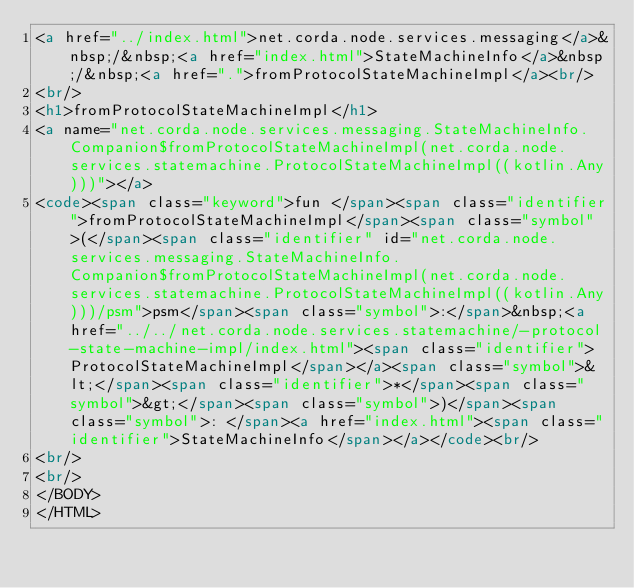Convert code to text. <code><loc_0><loc_0><loc_500><loc_500><_HTML_><a href="../index.html">net.corda.node.services.messaging</a>&nbsp;/&nbsp;<a href="index.html">StateMachineInfo</a>&nbsp;/&nbsp;<a href=".">fromProtocolStateMachineImpl</a><br/>
<br/>
<h1>fromProtocolStateMachineImpl</h1>
<a name="net.corda.node.services.messaging.StateMachineInfo.Companion$fromProtocolStateMachineImpl(net.corda.node.services.statemachine.ProtocolStateMachineImpl((kotlin.Any)))"></a>
<code><span class="keyword">fun </span><span class="identifier">fromProtocolStateMachineImpl</span><span class="symbol">(</span><span class="identifier" id="net.corda.node.services.messaging.StateMachineInfo.Companion$fromProtocolStateMachineImpl(net.corda.node.services.statemachine.ProtocolStateMachineImpl((kotlin.Any)))/psm">psm</span><span class="symbol">:</span>&nbsp;<a href="../../net.corda.node.services.statemachine/-protocol-state-machine-impl/index.html"><span class="identifier">ProtocolStateMachineImpl</span></a><span class="symbol">&lt;</span><span class="identifier">*</span><span class="symbol">&gt;</span><span class="symbol">)</span><span class="symbol">: </span><a href="index.html"><span class="identifier">StateMachineInfo</span></a></code><br/>
<br/>
<br/>
</BODY>
</HTML>
</code> 